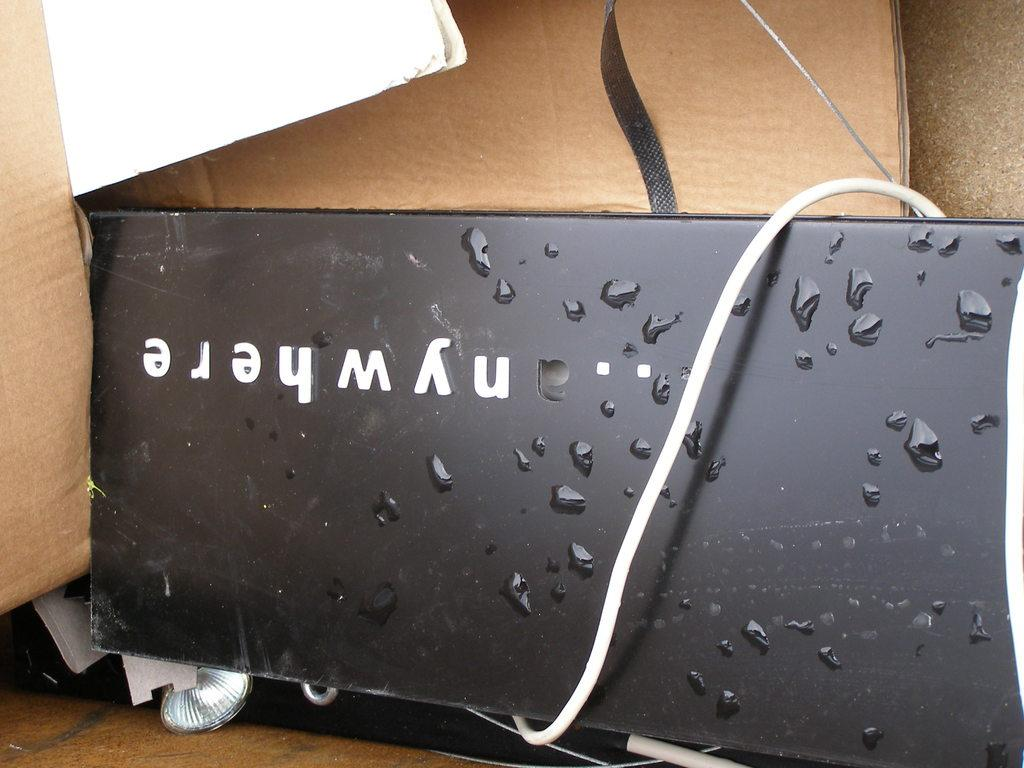<image>
Offer a succinct explanation of the picture presented. A black metal box with water drops on it says anywhere. 